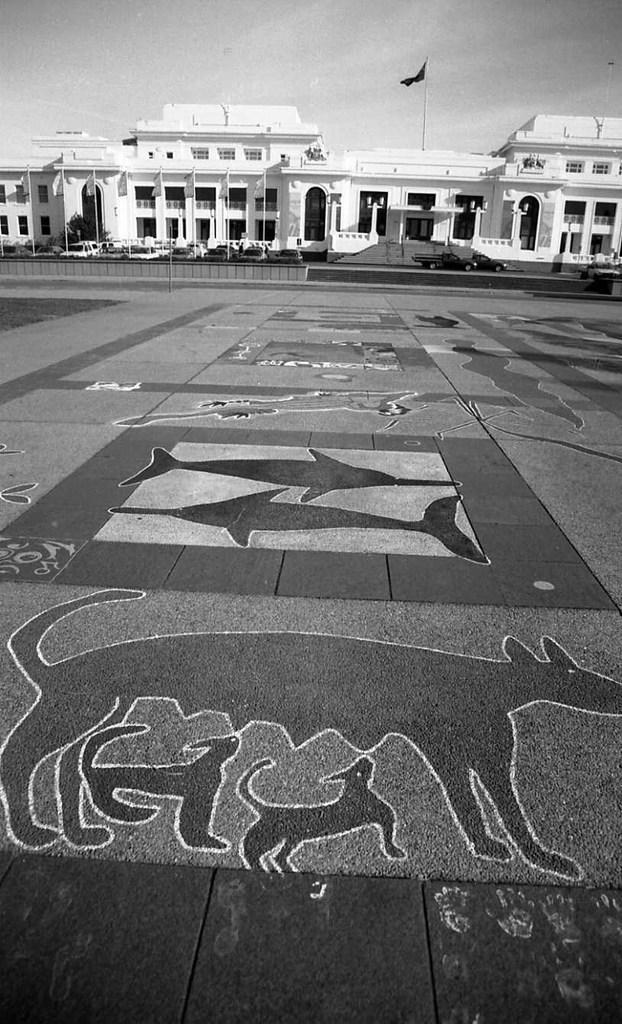How would you summarize this image in a sentence or two? In this image we can see there is a building and a flag. And there are vehicles on the road. There is a ground with design. And at the top there is the sky. 